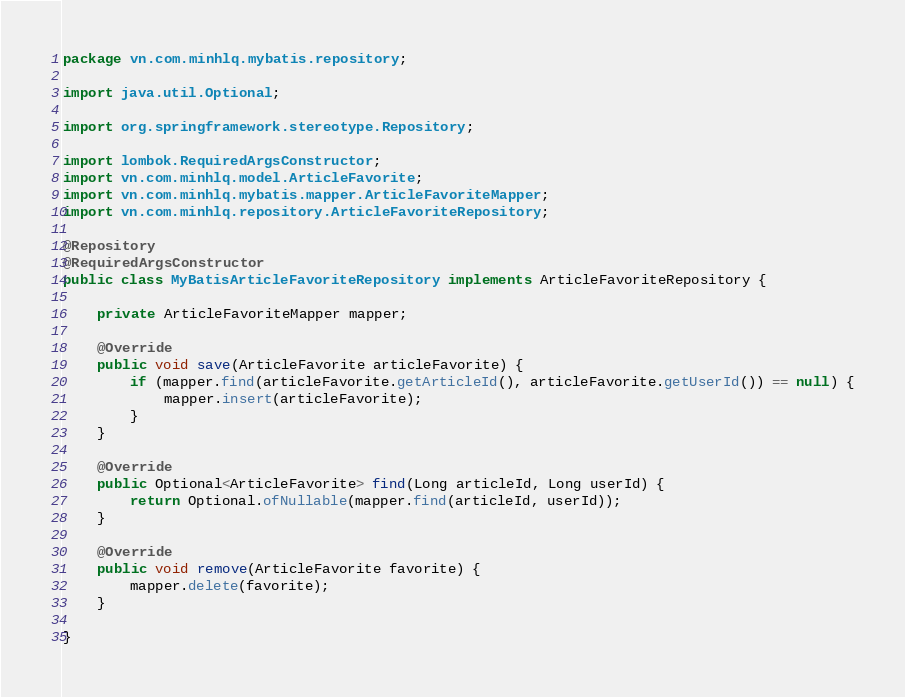<code> <loc_0><loc_0><loc_500><loc_500><_Java_>package vn.com.minhlq.mybatis.repository;

import java.util.Optional;

import org.springframework.stereotype.Repository;

import lombok.RequiredArgsConstructor;
import vn.com.minhlq.model.ArticleFavorite;
import vn.com.minhlq.mybatis.mapper.ArticleFavoriteMapper;
import vn.com.minhlq.repository.ArticleFavoriteRepository;

@Repository
@RequiredArgsConstructor
public class MyBatisArticleFavoriteRepository implements ArticleFavoriteRepository {

    private ArticleFavoriteMapper mapper;

    @Override
    public void save(ArticleFavorite articleFavorite) {
        if (mapper.find(articleFavorite.getArticleId(), articleFavorite.getUserId()) == null) {
            mapper.insert(articleFavorite);
        }
    }

    @Override
    public Optional<ArticleFavorite> find(Long articleId, Long userId) {
        return Optional.ofNullable(mapper.find(articleId, userId));
    }

    @Override
    public void remove(ArticleFavorite favorite) {
        mapper.delete(favorite);
    }

}
</code> 